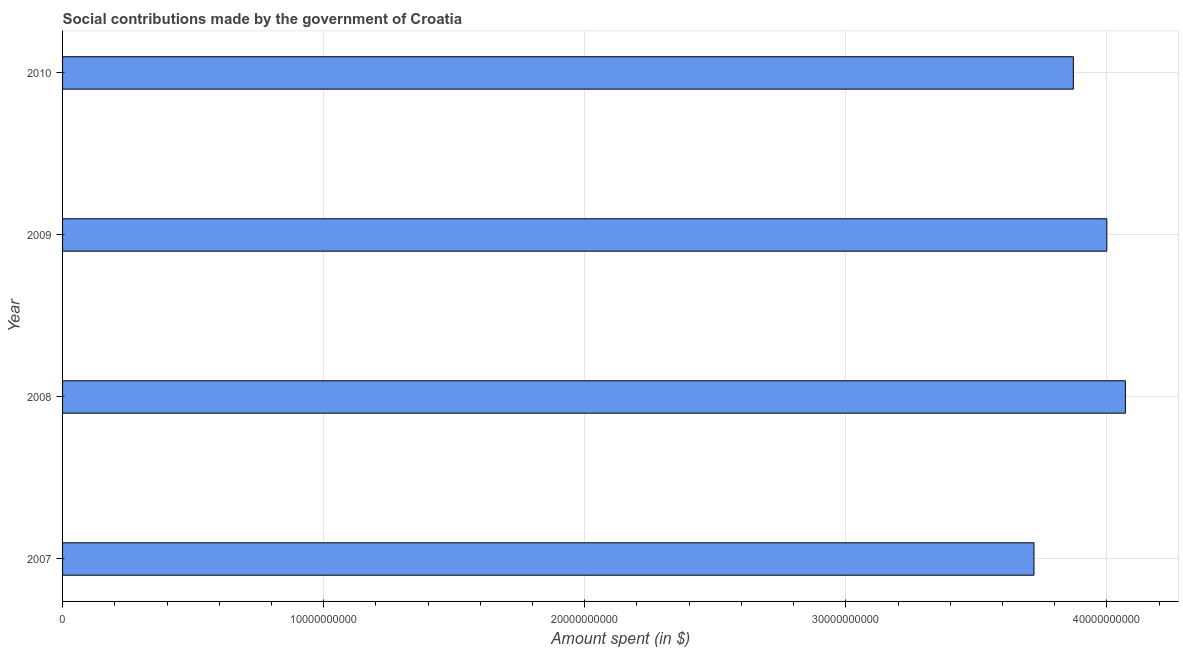Does the graph contain any zero values?
Provide a short and direct response. No. What is the title of the graph?
Your response must be concise. Social contributions made by the government of Croatia. What is the label or title of the X-axis?
Make the answer very short. Amount spent (in $). What is the amount spent in making social contributions in 2007?
Keep it short and to the point. 3.72e+1. Across all years, what is the maximum amount spent in making social contributions?
Your answer should be very brief. 4.07e+1. Across all years, what is the minimum amount spent in making social contributions?
Provide a succinct answer. 3.72e+1. In which year was the amount spent in making social contributions minimum?
Provide a short and direct response. 2007. What is the sum of the amount spent in making social contributions?
Provide a succinct answer. 1.57e+11. What is the difference between the amount spent in making social contributions in 2007 and 2008?
Your answer should be very brief. -3.50e+09. What is the average amount spent in making social contributions per year?
Offer a very short reply. 3.92e+1. What is the median amount spent in making social contributions?
Give a very brief answer. 3.94e+1. What is the ratio of the amount spent in making social contributions in 2009 to that in 2010?
Provide a succinct answer. 1.03. Is the amount spent in making social contributions in 2007 less than that in 2010?
Ensure brevity in your answer.  Yes. Is the difference between the amount spent in making social contributions in 2009 and 2010 greater than the difference between any two years?
Your answer should be compact. No. What is the difference between the highest and the second highest amount spent in making social contributions?
Offer a very short reply. 7.09e+08. Is the sum of the amount spent in making social contributions in 2007 and 2008 greater than the maximum amount spent in making social contributions across all years?
Provide a succinct answer. Yes. What is the difference between the highest and the lowest amount spent in making social contributions?
Keep it short and to the point. 3.50e+09. In how many years, is the amount spent in making social contributions greater than the average amount spent in making social contributions taken over all years?
Offer a terse response. 2. Are all the bars in the graph horizontal?
Provide a succinct answer. Yes. What is the difference between two consecutive major ticks on the X-axis?
Your answer should be very brief. 1.00e+1. What is the Amount spent (in $) in 2007?
Keep it short and to the point. 3.72e+1. What is the Amount spent (in $) in 2008?
Provide a short and direct response. 4.07e+1. What is the Amount spent (in $) of 2009?
Ensure brevity in your answer.  4.00e+1. What is the Amount spent (in $) in 2010?
Provide a succinct answer. 3.87e+1. What is the difference between the Amount spent (in $) in 2007 and 2008?
Make the answer very short. -3.50e+09. What is the difference between the Amount spent (in $) in 2007 and 2009?
Ensure brevity in your answer.  -2.79e+09. What is the difference between the Amount spent (in $) in 2007 and 2010?
Your answer should be very brief. -1.51e+09. What is the difference between the Amount spent (in $) in 2008 and 2009?
Offer a very short reply. 7.09e+08. What is the difference between the Amount spent (in $) in 2008 and 2010?
Provide a short and direct response. 1.99e+09. What is the difference between the Amount spent (in $) in 2009 and 2010?
Your response must be concise. 1.28e+09. What is the ratio of the Amount spent (in $) in 2007 to that in 2008?
Offer a very short reply. 0.91. What is the ratio of the Amount spent (in $) in 2007 to that in 2009?
Make the answer very short. 0.93. What is the ratio of the Amount spent (in $) in 2008 to that in 2009?
Your answer should be very brief. 1.02. What is the ratio of the Amount spent (in $) in 2008 to that in 2010?
Provide a short and direct response. 1.05. What is the ratio of the Amount spent (in $) in 2009 to that in 2010?
Give a very brief answer. 1.03. 